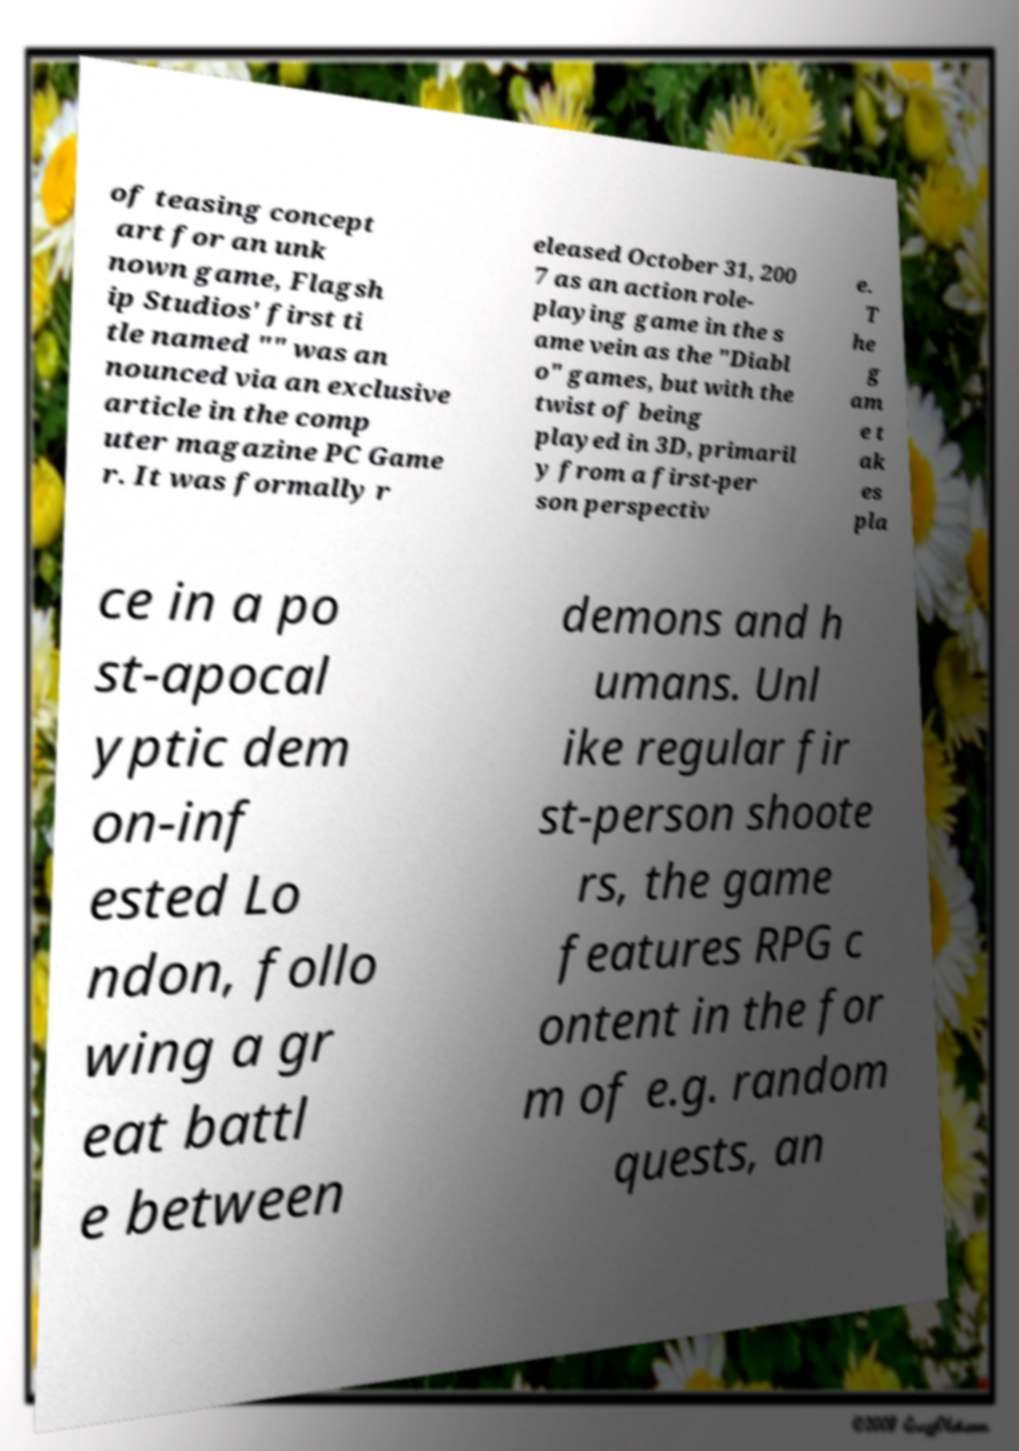Can you read and provide the text displayed in the image?This photo seems to have some interesting text. Can you extract and type it out for me? of teasing concept art for an unk nown game, Flagsh ip Studios' first ti tle named "" was an nounced via an exclusive article in the comp uter magazine PC Game r. It was formally r eleased October 31, 200 7 as an action role- playing game in the s ame vein as the "Diabl o" games, but with the twist of being played in 3D, primaril y from a first-per son perspectiv e. T he g am e t ak es pla ce in a po st-apocal yptic dem on-inf ested Lo ndon, follo wing a gr eat battl e between demons and h umans. Unl ike regular fir st-person shoote rs, the game features RPG c ontent in the for m of e.g. random quests, an 